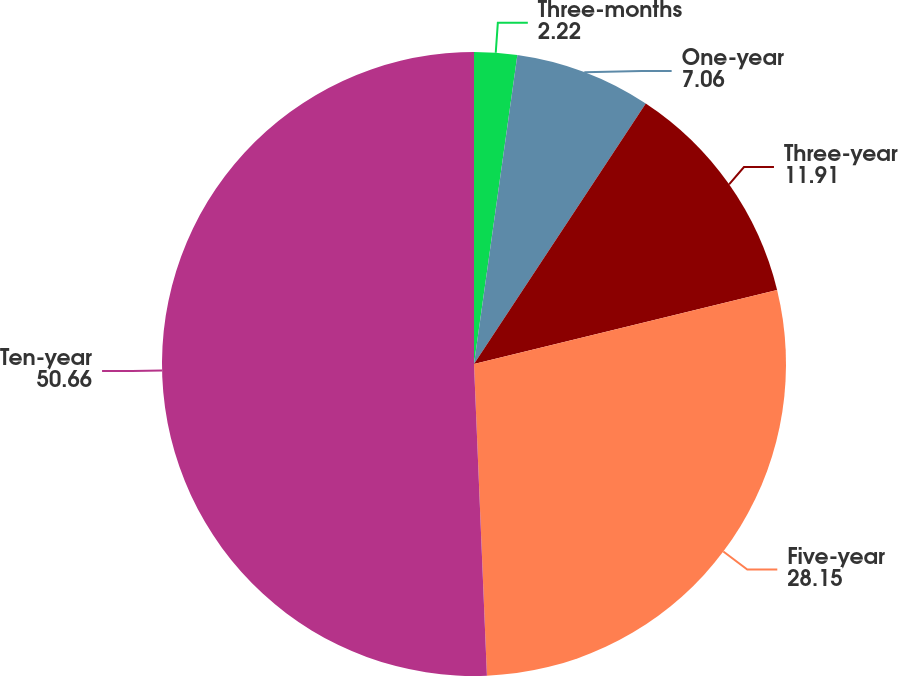Convert chart to OTSL. <chart><loc_0><loc_0><loc_500><loc_500><pie_chart><fcel>Three-months<fcel>One-year<fcel>Three-year<fcel>Five-year<fcel>Ten-year<nl><fcel>2.22%<fcel>7.06%<fcel>11.91%<fcel>28.15%<fcel>50.66%<nl></chart> 